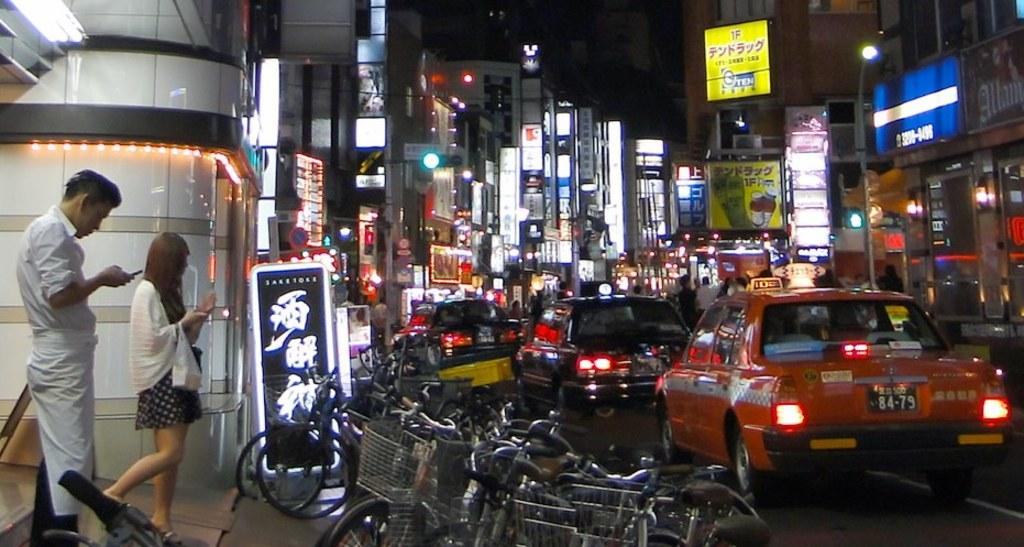<image>
Give a short and clear explanation of the subsequent image. Very busy Asian down town area, full of shop and cars with many bill boards in Asian characteristics. 